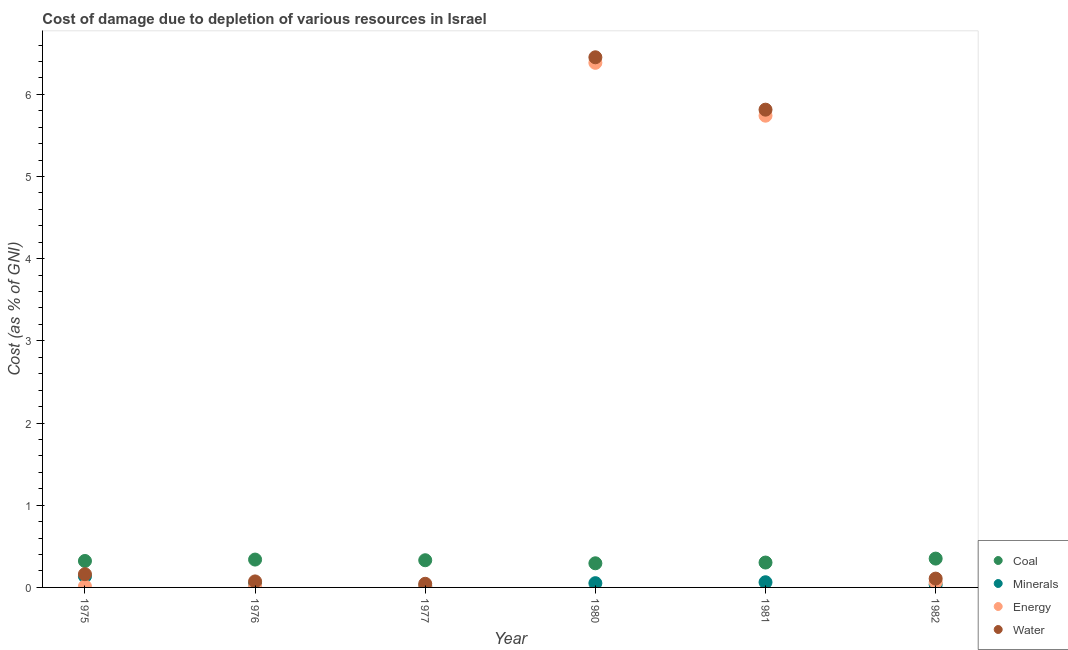How many different coloured dotlines are there?
Ensure brevity in your answer.  4. What is the cost of damage due to depletion of minerals in 1977?
Your response must be concise. 0.02. Across all years, what is the maximum cost of damage due to depletion of coal?
Keep it short and to the point. 0.35. Across all years, what is the minimum cost of damage due to depletion of energy?
Give a very brief answer. 0.01. What is the total cost of damage due to depletion of water in the graph?
Keep it short and to the point. 12.65. What is the difference between the cost of damage due to depletion of coal in 1980 and that in 1981?
Offer a very short reply. -0.01. What is the difference between the cost of damage due to depletion of water in 1980 and the cost of damage due to depletion of coal in 1977?
Give a very brief answer. 6.12. What is the average cost of damage due to depletion of minerals per year?
Ensure brevity in your answer.  0.06. In the year 1976, what is the difference between the cost of damage due to depletion of coal and cost of damage due to depletion of water?
Keep it short and to the point. 0.27. What is the ratio of the cost of damage due to depletion of coal in 1976 to that in 1981?
Your response must be concise. 1.12. Is the cost of damage due to depletion of minerals in 1976 less than that in 1981?
Your answer should be compact. Yes. Is the difference between the cost of damage due to depletion of coal in 1980 and 1982 greater than the difference between the cost of damage due to depletion of energy in 1980 and 1982?
Your answer should be compact. No. What is the difference between the highest and the second highest cost of damage due to depletion of energy?
Give a very brief answer. 0.64. What is the difference between the highest and the lowest cost of damage due to depletion of coal?
Make the answer very short. 0.06. Is the sum of the cost of damage due to depletion of coal in 1975 and 1980 greater than the maximum cost of damage due to depletion of energy across all years?
Keep it short and to the point. No. Is it the case that in every year, the sum of the cost of damage due to depletion of coal and cost of damage due to depletion of energy is greater than the sum of cost of damage due to depletion of minerals and cost of damage due to depletion of water?
Provide a succinct answer. No. Does the cost of damage due to depletion of minerals monotonically increase over the years?
Make the answer very short. No. Does the graph contain any zero values?
Your response must be concise. No. Where does the legend appear in the graph?
Ensure brevity in your answer.  Bottom right. How many legend labels are there?
Offer a terse response. 4. What is the title of the graph?
Provide a short and direct response. Cost of damage due to depletion of various resources in Israel . Does "Primary" appear as one of the legend labels in the graph?
Offer a very short reply. No. What is the label or title of the X-axis?
Offer a terse response. Year. What is the label or title of the Y-axis?
Your answer should be very brief. Cost (as % of GNI). What is the Cost (as % of GNI) of Coal in 1975?
Your answer should be very brief. 0.32. What is the Cost (as % of GNI) in Minerals in 1975?
Offer a very short reply. 0.13. What is the Cost (as % of GNI) in Energy in 1975?
Give a very brief answer. 0.01. What is the Cost (as % of GNI) of Water in 1975?
Make the answer very short. 0.16. What is the Cost (as % of GNI) of Coal in 1976?
Your response must be concise. 0.34. What is the Cost (as % of GNI) of Minerals in 1976?
Give a very brief answer. 0.04. What is the Cost (as % of GNI) in Energy in 1976?
Your answer should be compact. 0.01. What is the Cost (as % of GNI) in Water in 1976?
Your answer should be very brief. 0.07. What is the Cost (as % of GNI) in Coal in 1977?
Ensure brevity in your answer.  0.33. What is the Cost (as % of GNI) in Minerals in 1977?
Your answer should be compact. 0.02. What is the Cost (as % of GNI) of Energy in 1977?
Your answer should be compact. 0.01. What is the Cost (as % of GNI) of Water in 1977?
Offer a terse response. 0.04. What is the Cost (as % of GNI) of Coal in 1980?
Provide a succinct answer. 0.29. What is the Cost (as % of GNI) in Minerals in 1980?
Offer a terse response. 0.05. What is the Cost (as % of GNI) in Energy in 1980?
Give a very brief answer. 6.38. What is the Cost (as % of GNI) in Water in 1980?
Provide a succinct answer. 6.45. What is the Cost (as % of GNI) of Coal in 1981?
Your answer should be very brief. 0.3. What is the Cost (as % of GNI) of Minerals in 1981?
Give a very brief answer. 0.06. What is the Cost (as % of GNI) in Energy in 1981?
Your answer should be very brief. 5.74. What is the Cost (as % of GNI) in Water in 1981?
Your response must be concise. 5.81. What is the Cost (as % of GNI) in Coal in 1982?
Give a very brief answer. 0.35. What is the Cost (as % of GNI) of Minerals in 1982?
Provide a succinct answer. 0.03. What is the Cost (as % of GNI) in Energy in 1982?
Ensure brevity in your answer.  0.06. What is the Cost (as % of GNI) of Water in 1982?
Your answer should be compact. 0.11. Across all years, what is the maximum Cost (as % of GNI) of Coal?
Provide a succinct answer. 0.35. Across all years, what is the maximum Cost (as % of GNI) of Minerals?
Offer a very short reply. 0.13. Across all years, what is the maximum Cost (as % of GNI) in Energy?
Make the answer very short. 6.38. Across all years, what is the maximum Cost (as % of GNI) in Water?
Provide a short and direct response. 6.45. Across all years, what is the minimum Cost (as % of GNI) of Coal?
Offer a terse response. 0.29. Across all years, what is the minimum Cost (as % of GNI) of Minerals?
Provide a short and direct response. 0.02. Across all years, what is the minimum Cost (as % of GNI) in Energy?
Provide a short and direct response. 0.01. Across all years, what is the minimum Cost (as % of GNI) of Water?
Offer a terse response. 0.04. What is the total Cost (as % of GNI) of Coal in the graph?
Offer a very short reply. 1.94. What is the total Cost (as % of GNI) of Minerals in the graph?
Make the answer very short. 0.35. What is the total Cost (as % of GNI) of Energy in the graph?
Keep it short and to the point. 12.22. What is the total Cost (as % of GNI) of Water in the graph?
Provide a succinct answer. 12.65. What is the difference between the Cost (as % of GNI) of Coal in 1975 and that in 1976?
Keep it short and to the point. -0.02. What is the difference between the Cost (as % of GNI) in Minerals in 1975 and that in 1976?
Provide a succinct answer. 0.09. What is the difference between the Cost (as % of GNI) in Energy in 1975 and that in 1976?
Your answer should be very brief. 0. What is the difference between the Cost (as % of GNI) of Water in 1975 and that in 1976?
Your answer should be compact. 0.09. What is the difference between the Cost (as % of GNI) of Coal in 1975 and that in 1977?
Provide a short and direct response. -0.01. What is the difference between the Cost (as % of GNI) in Minerals in 1975 and that in 1977?
Ensure brevity in your answer.  0.12. What is the difference between the Cost (as % of GNI) of Energy in 1975 and that in 1977?
Your response must be concise. 0. What is the difference between the Cost (as % of GNI) in Water in 1975 and that in 1977?
Provide a short and direct response. 0.12. What is the difference between the Cost (as % of GNI) of Coal in 1975 and that in 1980?
Keep it short and to the point. 0.03. What is the difference between the Cost (as % of GNI) of Minerals in 1975 and that in 1980?
Provide a short and direct response. 0.08. What is the difference between the Cost (as % of GNI) of Energy in 1975 and that in 1980?
Your response must be concise. -6.37. What is the difference between the Cost (as % of GNI) in Water in 1975 and that in 1980?
Provide a short and direct response. -6.29. What is the difference between the Cost (as % of GNI) in Coal in 1975 and that in 1981?
Offer a very short reply. 0.02. What is the difference between the Cost (as % of GNI) of Minerals in 1975 and that in 1981?
Your response must be concise. 0.07. What is the difference between the Cost (as % of GNI) of Energy in 1975 and that in 1981?
Make the answer very short. -5.73. What is the difference between the Cost (as % of GNI) in Water in 1975 and that in 1981?
Keep it short and to the point. -5.65. What is the difference between the Cost (as % of GNI) in Coal in 1975 and that in 1982?
Your answer should be very brief. -0.03. What is the difference between the Cost (as % of GNI) in Minerals in 1975 and that in 1982?
Ensure brevity in your answer.  0.1. What is the difference between the Cost (as % of GNI) of Energy in 1975 and that in 1982?
Ensure brevity in your answer.  -0.05. What is the difference between the Cost (as % of GNI) in Water in 1975 and that in 1982?
Give a very brief answer. 0.05. What is the difference between the Cost (as % of GNI) of Coal in 1976 and that in 1977?
Offer a terse response. 0.01. What is the difference between the Cost (as % of GNI) in Minerals in 1976 and that in 1977?
Your answer should be compact. 0.03. What is the difference between the Cost (as % of GNI) in Energy in 1976 and that in 1977?
Ensure brevity in your answer.  0. What is the difference between the Cost (as % of GNI) of Water in 1976 and that in 1977?
Your answer should be very brief. 0.03. What is the difference between the Cost (as % of GNI) of Coal in 1976 and that in 1980?
Ensure brevity in your answer.  0.05. What is the difference between the Cost (as % of GNI) in Minerals in 1976 and that in 1980?
Ensure brevity in your answer.  -0.01. What is the difference between the Cost (as % of GNI) of Energy in 1976 and that in 1980?
Provide a succinct answer. -6.37. What is the difference between the Cost (as % of GNI) of Water in 1976 and that in 1980?
Your answer should be very brief. -6.38. What is the difference between the Cost (as % of GNI) of Coal in 1976 and that in 1981?
Your answer should be compact. 0.04. What is the difference between the Cost (as % of GNI) of Minerals in 1976 and that in 1981?
Your answer should be compact. -0.02. What is the difference between the Cost (as % of GNI) in Energy in 1976 and that in 1981?
Your response must be concise. -5.73. What is the difference between the Cost (as % of GNI) in Water in 1976 and that in 1981?
Provide a succinct answer. -5.74. What is the difference between the Cost (as % of GNI) of Coal in 1976 and that in 1982?
Your answer should be compact. -0.01. What is the difference between the Cost (as % of GNI) in Minerals in 1976 and that in 1982?
Ensure brevity in your answer.  0.01. What is the difference between the Cost (as % of GNI) in Energy in 1976 and that in 1982?
Provide a succinct answer. -0.05. What is the difference between the Cost (as % of GNI) in Water in 1976 and that in 1982?
Provide a succinct answer. -0.03. What is the difference between the Cost (as % of GNI) in Coal in 1977 and that in 1980?
Provide a short and direct response. 0.04. What is the difference between the Cost (as % of GNI) in Minerals in 1977 and that in 1980?
Your answer should be compact. -0.03. What is the difference between the Cost (as % of GNI) of Energy in 1977 and that in 1980?
Provide a succinct answer. -6.37. What is the difference between the Cost (as % of GNI) of Water in 1977 and that in 1980?
Your answer should be compact. -6.41. What is the difference between the Cost (as % of GNI) in Coal in 1977 and that in 1981?
Your answer should be very brief. 0.03. What is the difference between the Cost (as % of GNI) in Minerals in 1977 and that in 1981?
Ensure brevity in your answer.  -0.05. What is the difference between the Cost (as % of GNI) in Energy in 1977 and that in 1981?
Your answer should be very brief. -5.73. What is the difference between the Cost (as % of GNI) of Water in 1977 and that in 1981?
Your answer should be very brief. -5.77. What is the difference between the Cost (as % of GNI) of Coal in 1977 and that in 1982?
Offer a terse response. -0.02. What is the difference between the Cost (as % of GNI) of Minerals in 1977 and that in 1982?
Offer a terse response. -0.02. What is the difference between the Cost (as % of GNI) of Energy in 1977 and that in 1982?
Give a very brief answer. -0.05. What is the difference between the Cost (as % of GNI) in Water in 1977 and that in 1982?
Your answer should be very brief. -0.06. What is the difference between the Cost (as % of GNI) in Coal in 1980 and that in 1981?
Make the answer very short. -0.01. What is the difference between the Cost (as % of GNI) of Minerals in 1980 and that in 1981?
Your response must be concise. -0.01. What is the difference between the Cost (as % of GNI) of Energy in 1980 and that in 1981?
Provide a succinct answer. 0.64. What is the difference between the Cost (as % of GNI) of Water in 1980 and that in 1981?
Provide a succinct answer. 0.64. What is the difference between the Cost (as % of GNI) in Coal in 1980 and that in 1982?
Keep it short and to the point. -0.06. What is the difference between the Cost (as % of GNI) of Minerals in 1980 and that in 1982?
Your response must be concise. 0.02. What is the difference between the Cost (as % of GNI) in Energy in 1980 and that in 1982?
Your answer should be very brief. 6.32. What is the difference between the Cost (as % of GNI) of Water in 1980 and that in 1982?
Provide a short and direct response. 6.34. What is the difference between the Cost (as % of GNI) in Coal in 1981 and that in 1982?
Ensure brevity in your answer.  -0.05. What is the difference between the Cost (as % of GNI) in Minerals in 1981 and that in 1982?
Provide a succinct answer. 0.03. What is the difference between the Cost (as % of GNI) in Energy in 1981 and that in 1982?
Your response must be concise. 5.68. What is the difference between the Cost (as % of GNI) in Water in 1981 and that in 1982?
Offer a very short reply. 5.71. What is the difference between the Cost (as % of GNI) of Coal in 1975 and the Cost (as % of GNI) of Minerals in 1976?
Your response must be concise. 0.28. What is the difference between the Cost (as % of GNI) in Coal in 1975 and the Cost (as % of GNI) in Energy in 1976?
Your answer should be compact. 0.31. What is the difference between the Cost (as % of GNI) of Coal in 1975 and the Cost (as % of GNI) of Water in 1976?
Keep it short and to the point. 0.25. What is the difference between the Cost (as % of GNI) of Minerals in 1975 and the Cost (as % of GNI) of Energy in 1976?
Ensure brevity in your answer.  0.12. What is the difference between the Cost (as % of GNI) in Minerals in 1975 and the Cost (as % of GNI) in Water in 1976?
Ensure brevity in your answer.  0.06. What is the difference between the Cost (as % of GNI) of Energy in 1975 and the Cost (as % of GNI) of Water in 1976?
Provide a succinct answer. -0.06. What is the difference between the Cost (as % of GNI) in Coal in 1975 and the Cost (as % of GNI) in Minerals in 1977?
Provide a short and direct response. 0.3. What is the difference between the Cost (as % of GNI) of Coal in 1975 and the Cost (as % of GNI) of Energy in 1977?
Your answer should be very brief. 0.31. What is the difference between the Cost (as % of GNI) in Coal in 1975 and the Cost (as % of GNI) in Water in 1977?
Your response must be concise. 0.28. What is the difference between the Cost (as % of GNI) of Minerals in 1975 and the Cost (as % of GNI) of Energy in 1977?
Your answer should be very brief. 0.12. What is the difference between the Cost (as % of GNI) of Minerals in 1975 and the Cost (as % of GNI) of Water in 1977?
Offer a terse response. 0.09. What is the difference between the Cost (as % of GNI) of Energy in 1975 and the Cost (as % of GNI) of Water in 1977?
Your answer should be very brief. -0.03. What is the difference between the Cost (as % of GNI) in Coal in 1975 and the Cost (as % of GNI) in Minerals in 1980?
Keep it short and to the point. 0.27. What is the difference between the Cost (as % of GNI) in Coal in 1975 and the Cost (as % of GNI) in Energy in 1980?
Make the answer very short. -6.06. What is the difference between the Cost (as % of GNI) in Coal in 1975 and the Cost (as % of GNI) in Water in 1980?
Provide a succinct answer. -6.13. What is the difference between the Cost (as % of GNI) of Minerals in 1975 and the Cost (as % of GNI) of Energy in 1980?
Your answer should be very brief. -6.25. What is the difference between the Cost (as % of GNI) in Minerals in 1975 and the Cost (as % of GNI) in Water in 1980?
Make the answer very short. -6.32. What is the difference between the Cost (as % of GNI) in Energy in 1975 and the Cost (as % of GNI) in Water in 1980?
Your response must be concise. -6.44. What is the difference between the Cost (as % of GNI) of Coal in 1975 and the Cost (as % of GNI) of Minerals in 1981?
Make the answer very short. 0.26. What is the difference between the Cost (as % of GNI) of Coal in 1975 and the Cost (as % of GNI) of Energy in 1981?
Give a very brief answer. -5.42. What is the difference between the Cost (as % of GNI) of Coal in 1975 and the Cost (as % of GNI) of Water in 1981?
Make the answer very short. -5.49. What is the difference between the Cost (as % of GNI) of Minerals in 1975 and the Cost (as % of GNI) of Energy in 1981?
Ensure brevity in your answer.  -5.61. What is the difference between the Cost (as % of GNI) in Minerals in 1975 and the Cost (as % of GNI) in Water in 1981?
Your answer should be very brief. -5.68. What is the difference between the Cost (as % of GNI) in Energy in 1975 and the Cost (as % of GNI) in Water in 1981?
Your answer should be compact. -5.8. What is the difference between the Cost (as % of GNI) of Coal in 1975 and the Cost (as % of GNI) of Minerals in 1982?
Offer a terse response. 0.29. What is the difference between the Cost (as % of GNI) in Coal in 1975 and the Cost (as % of GNI) in Energy in 1982?
Provide a succinct answer. 0.26. What is the difference between the Cost (as % of GNI) of Coal in 1975 and the Cost (as % of GNI) of Water in 1982?
Keep it short and to the point. 0.21. What is the difference between the Cost (as % of GNI) of Minerals in 1975 and the Cost (as % of GNI) of Energy in 1982?
Provide a short and direct response. 0.07. What is the difference between the Cost (as % of GNI) in Minerals in 1975 and the Cost (as % of GNI) in Water in 1982?
Your answer should be very brief. 0.03. What is the difference between the Cost (as % of GNI) in Energy in 1975 and the Cost (as % of GNI) in Water in 1982?
Your answer should be compact. -0.09. What is the difference between the Cost (as % of GNI) in Coal in 1976 and the Cost (as % of GNI) in Minerals in 1977?
Ensure brevity in your answer.  0.32. What is the difference between the Cost (as % of GNI) in Coal in 1976 and the Cost (as % of GNI) in Energy in 1977?
Make the answer very short. 0.33. What is the difference between the Cost (as % of GNI) of Coal in 1976 and the Cost (as % of GNI) of Water in 1977?
Your answer should be very brief. 0.29. What is the difference between the Cost (as % of GNI) in Minerals in 1976 and the Cost (as % of GNI) in Energy in 1977?
Your answer should be compact. 0.03. What is the difference between the Cost (as % of GNI) in Minerals in 1976 and the Cost (as % of GNI) in Water in 1977?
Your response must be concise. -0. What is the difference between the Cost (as % of GNI) of Energy in 1976 and the Cost (as % of GNI) of Water in 1977?
Your answer should be compact. -0.03. What is the difference between the Cost (as % of GNI) in Coal in 1976 and the Cost (as % of GNI) in Minerals in 1980?
Your answer should be very brief. 0.29. What is the difference between the Cost (as % of GNI) in Coal in 1976 and the Cost (as % of GNI) in Energy in 1980?
Your response must be concise. -6.04. What is the difference between the Cost (as % of GNI) of Coal in 1976 and the Cost (as % of GNI) of Water in 1980?
Keep it short and to the point. -6.11. What is the difference between the Cost (as % of GNI) of Minerals in 1976 and the Cost (as % of GNI) of Energy in 1980?
Your answer should be very brief. -6.34. What is the difference between the Cost (as % of GNI) of Minerals in 1976 and the Cost (as % of GNI) of Water in 1980?
Make the answer very short. -6.41. What is the difference between the Cost (as % of GNI) in Energy in 1976 and the Cost (as % of GNI) in Water in 1980?
Give a very brief answer. -6.44. What is the difference between the Cost (as % of GNI) of Coal in 1976 and the Cost (as % of GNI) of Minerals in 1981?
Your answer should be compact. 0.28. What is the difference between the Cost (as % of GNI) in Coal in 1976 and the Cost (as % of GNI) in Energy in 1981?
Ensure brevity in your answer.  -5.4. What is the difference between the Cost (as % of GNI) of Coal in 1976 and the Cost (as % of GNI) of Water in 1981?
Provide a succinct answer. -5.47. What is the difference between the Cost (as % of GNI) of Minerals in 1976 and the Cost (as % of GNI) of Energy in 1981?
Your response must be concise. -5.7. What is the difference between the Cost (as % of GNI) in Minerals in 1976 and the Cost (as % of GNI) in Water in 1981?
Provide a short and direct response. -5.77. What is the difference between the Cost (as % of GNI) in Energy in 1976 and the Cost (as % of GNI) in Water in 1981?
Your answer should be compact. -5.8. What is the difference between the Cost (as % of GNI) of Coal in 1976 and the Cost (as % of GNI) of Minerals in 1982?
Keep it short and to the point. 0.3. What is the difference between the Cost (as % of GNI) in Coal in 1976 and the Cost (as % of GNI) in Energy in 1982?
Provide a succinct answer. 0.28. What is the difference between the Cost (as % of GNI) of Coal in 1976 and the Cost (as % of GNI) of Water in 1982?
Offer a very short reply. 0.23. What is the difference between the Cost (as % of GNI) of Minerals in 1976 and the Cost (as % of GNI) of Energy in 1982?
Your answer should be very brief. -0.02. What is the difference between the Cost (as % of GNI) of Minerals in 1976 and the Cost (as % of GNI) of Water in 1982?
Your answer should be compact. -0.06. What is the difference between the Cost (as % of GNI) in Energy in 1976 and the Cost (as % of GNI) in Water in 1982?
Your response must be concise. -0.09. What is the difference between the Cost (as % of GNI) in Coal in 1977 and the Cost (as % of GNI) in Minerals in 1980?
Your answer should be compact. 0.28. What is the difference between the Cost (as % of GNI) of Coal in 1977 and the Cost (as % of GNI) of Energy in 1980?
Your response must be concise. -6.05. What is the difference between the Cost (as % of GNI) of Coal in 1977 and the Cost (as % of GNI) of Water in 1980?
Provide a succinct answer. -6.12. What is the difference between the Cost (as % of GNI) of Minerals in 1977 and the Cost (as % of GNI) of Energy in 1980?
Offer a terse response. -6.37. What is the difference between the Cost (as % of GNI) in Minerals in 1977 and the Cost (as % of GNI) in Water in 1980?
Your answer should be very brief. -6.43. What is the difference between the Cost (as % of GNI) in Energy in 1977 and the Cost (as % of GNI) in Water in 1980?
Ensure brevity in your answer.  -6.44. What is the difference between the Cost (as % of GNI) in Coal in 1977 and the Cost (as % of GNI) in Minerals in 1981?
Provide a short and direct response. 0.27. What is the difference between the Cost (as % of GNI) in Coal in 1977 and the Cost (as % of GNI) in Energy in 1981?
Your answer should be compact. -5.41. What is the difference between the Cost (as % of GNI) of Coal in 1977 and the Cost (as % of GNI) of Water in 1981?
Provide a succinct answer. -5.48. What is the difference between the Cost (as % of GNI) in Minerals in 1977 and the Cost (as % of GNI) in Energy in 1981?
Offer a terse response. -5.72. What is the difference between the Cost (as % of GNI) of Minerals in 1977 and the Cost (as % of GNI) of Water in 1981?
Offer a terse response. -5.8. What is the difference between the Cost (as % of GNI) of Energy in 1977 and the Cost (as % of GNI) of Water in 1981?
Ensure brevity in your answer.  -5.8. What is the difference between the Cost (as % of GNI) of Coal in 1977 and the Cost (as % of GNI) of Minerals in 1982?
Offer a very short reply. 0.3. What is the difference between the Cost (as % of GNI) of Coal in 1977 and the Cost (as % of GNI) of Energy in 1982?
Your answer should be compact. 0.27. What is the difference between the Cost (as % of GNI) in Coal in 1977 and the Cost (as % of GNI) in Water in 1982?
Your answer should be very brief. 0.22. What is the difference between the Cost (as % of GNI) in Minerals in 1977 and the Cost (as % of GNI) in Energy in 1982?
Your answer should be very brief. -0.05. What is the difference between the Cost (as % of GNI) in Minerals in 1977 and the Cost (as % of GNI) in Water in 1982?
Make the answer very short. -0.09. What is the difference between the Cost (as % of GNI) of Energy in 1977 and the Cost (as % of GNI) of Water in 1982?
Your answer should be compact. -0.1. What is the difference between the Cost (as % of GNI) in Coal in 1980 and the Cost (as % of GNI) in Minerals in 1981?
Provide a short and direct response. 0.23. What is the difference between the Cost (as % of GNI) in Coal in 1980 and the Cost (as % of GNI) in Energy in 1981?
Your answer should be compact. -5.45. What is the difference between the Cost (as % of GNI) of Coal in 1980 and the Cost (as % of GNI) of Water in 1981?
Offer a very short reply. -5.52. What is the difference between the Cost (as % of GNI) of Minerals in 1980 and the Cost (as % of GNI) of Energy in 1981?
Your answer should be compact. -5.69. What is the difference between the Cost (as % of GNI) of Minerals in 1980 and the Cost (as % of GNI) of Water in 1981?
Give a very brief answer. -5.76. What is the difference between the Cost (as % of GNI) of Energy in 1980 and the Cost (as % of GNI) of Water in 1981?
Ensure brevity in your answer.  0.57. What is the difference between the Cost (as % of GNI) of Coal in 1980 and the Cost (as % of GNI) of Minerals in 1982?
Make the answer very short. 0.26. What is the difference between the Cost (as % of GNI) of Coal in 1980 and the Cost (as % of GNI) of Energy in 1982?
Your response must be concise. 0.23. What is the difference between the Cost (as % of GNI) in Coal in 1980 and the Cost (as % of GNI) in Water in 1982?
Your answer should be compact. 0.19. What is the difference between the Cost (as % of GNI) of Minerals in 1980 and the Cost (as % of GNI) of Energy in 1982?
Your response must be concise. -0.01. What is the difference between the Cost (as % of GNI) in Minerals in 1980 and the Cost (as % of GNI) in Water in 1982?
Offer a terse response. -0.06. What is the difference between the Cost (as % of GNI) of Energy in 1980 and the Cost (as % of GNI) of Water in 1982?
Provide a short and direct response. 6.28. What is the difference between the Cost (as % of GNI) in Coal in 1981 and the Cost (as % of GNI) in Minerals in 1982?
Ensure brevity in your answer.  0.27. What is the difference between the Cost (as % of GNI) in Coal in 1981 and the Cost (as % of GNI) in Energy in 1982?
Offer a very short reply. 0.24. What is the difference between the Cost (as % of GNI) in Coal in 1981 and the Cost (as % of GNI) in Water in 1982?
Provide a succinct answer. 0.2. What is the difference between the Cost (as % of GNI) in Minerals in 1981 and the Cost (as % of GNI) in Water in 1982?
Make the answer very short. -0.04. What is the difference between the Cost (as % of GNI) of Energy in 1981 and the Cost (as % of GNI) of Water in 1982?
Your response must be concise. 5.63. What is the average Cost (as % of GNI) in Coal per year?
Provide a succinct answer. 0.32. What is the average Cost (as % of GNI) of Minerals per year?
Offer a very short reply. 0.06. What is the average Cost (as % of GNI) of Energy per year?
Ensure brevity in your answer.  2.04. What is the average Cost (as % of GNI) in Water per year?
Your response must be concise. 2.11. In the year 1975, what is the difference between the Cost (as % of GNI) in Coal and Cost (as % of GNI) in Minerals?
Your answer should be compact. 0.19. In the year 1975, what is the difference between the Cost (as % of GNI) of Coal and Cost (as % of GNI) of Energy?
Your answer should be very brief. 0.31. In the year 1975, what is the difference between the Cost (as % of GNI) in Coal and Cost (as % of GNI) in Water?
Keep it short and to the point. 0.16. In the year 1975, what is the difference between the Cost (as % of GNI) in Minerals and Cost (as % of GNI) in Energy?
Your answer should be compact. 0.12. In the year 1975, what is the difference between the Cost (as % of GNI) in Minerals and Cost (as % of GNI) in Water?
Your answer should be compact. -0.03. In the year 1975, what is the difference between the Cost (as % of GNI) of Energy and Cost (as % of GNI) of Water?
Your answer should be compact. -0.15. In the year 1976, what is the difference between the Cost (as % of GNI) in Coal and Cost (as % of GNI) in Minerals?
Ensure brevity in your answer.  0.3. In the year 1976, what is the difference between the Cost (as % of GNI) in Coal and Cost (as % of GNI) in Energy?
Ensure brevity in your answer.  0.33. In the year 1976, what is the difference between the Cost (as % of GNI) in Coal and Cost (as % of GNI) in Water?
Make the answer very short. 0.27. In the year 1976, what is the difference between the Cost (as % of GNI) in Minerals and Cost (as % of GNI) in Energy?
Give a very brief answer. 0.03. In the year 1976, what is the difference between the Cost (as % of GNI) of Minerals and Cost (as % of GNI) of Water?
Make the answer very short. -0.03. In the year 1976, what is the difference between the Cost (as % of GNI) in Energy and Cost (as % of GNI) in Water?
Your answer should be very brief. -0.06. In the year 1977, what is the difference between the Cost (as % of GNI) in Coal and Cost (as % of GNI) in Minerals?
Provide a succinct answer. 0.31. In the year 1977, what is the difference between the Cost (as % of GNI) in Coal and Cost (as % of GNI) in Energy?
Give a very brief answer. 0.32. In the year 1977, what is the difference between the Cost (as % of GNI) in Coal and Cost (as % of GNI) in Water?
Your answer should be compact. 0.29. In the year 1977, what is the difference between the Cost (as % of GNI) of Minerals and Cost (as % of GNI) of Energy?
Keep it short and to the point. 0.01. In the year 1977, what is the difference between the Cost (as % of GNI) in Minerals and Cost (as % of GNI) in Water?
Provide a short and direct response. -0.03. In the year 1977, what is the difference between the Cost (as % of GNI) of Energy and Cost (as % of GNI) of Water?
Offer a very short reply. -0.03. In the year 1980, what is the difference between the Cost (as % of GNI) in Coal and Cost (as % of GNI) in Minerals?
Provide a short and direct response. 0.24. In the year 1980, what is the difference between the Cost (as % of GNI) of Coal and Cost (as % of GNI) of Energy?
Keep it short and to the point. -6.09. In the year 1980, what is the difference between the Cost (as % of GNI) in Coal and Cost (as % of GNI) in Water?
Your answer should be compact. -6.16. In the year 1980, what is the difference between the Cost (as % of GNI) of Minerals and Cost (as % of GNI) of Energy?
Your answer should be very brief. -6.33. In the year 1980, what is the difference between the Cost (as % of GNI) of Minerals and Cost (as % of GNI) of Water?
Provide a succinct answer. -6.4. In the year 1980, what is the difference between the Cost (as % of GNI) in Energy and Cost (as % of GNI) in Water?
Provide a short and direct response. -0.07. In the year 1981, what is the difference between the Cost (as % of GNI) in Coal and Cost (as % of GNI) in Minerals?
Keep it short and to the point. 0.24. In the year 1981, what is the difference between the Cost (as % of GNI) of Coal and Cost (as % of GNI) of Energy?
Your answer should be very brief. -5.44. In the year 1981, what is the difference between the Cost (as % of GNI) in Coal and Cost (as % of GNI) in Water?
Ensure brevity in your answer.  -5.51. In the year 1981, what is the difference between the Cost (as % of GNI) of Minerals and Cost (as % of GNI) of Energy?
Your answer should be compact. -5.68. In the year 1981, what is the difference between the Cost (as % of GNI) in Minerals and Cost (as % of GNI) in Water?
Provide a succinct answer. -5.75. In the year 1981, what is the difference between the Cost (as % of GNI) in Energy and Cost (as % of GNI) in Water?
Give a very brief answer. -0.07. In the year 1982, what is the difference between the Cost (as % of GNI) in Coal and Cost (as % of GNI) in Minerals?
Offer a very short reply. 0.32. In the year 1982, what is the difference between the Cost (as % of GNI) of Coal and Cost (as % of GNI) of Energy?
Provide a succinct answer. 0.29. In the year 1982, what is the difference between the Cost (as % of GNI) of Coal and Cost (as % of GNI) of Water?
Make the answer very short. 0.24. In the year 1982, what is the difference between the Cost (as % of GNI) of Minerals and Cost (as % of GNI) of Energy?
Offer a very short reply. -0.03. In the year 1982, what is the difference between the Cost (as % of GNI) of Minerals and Cost (as % of GNI) of Water?
Offer a very short reply. -0.07. In the year 1982, what is the difference between the Cost (as % of GNI) in Energy and Cost (as % of GNI) in Water?
Your response must be concise. -0.04. What is the ratio of the Cost (as % of GNI) in Coal in 1975 to that in 1976?
Your answer should be compact. 0.95. What is the ratio of the Cost (as % of GNI) of Minerals in 1975 to that in 1976?
Your answer should be very brief. 3.09. What is the ratio of the Cost (as % of GNI) of Energy in 1975 to that in 1976?
Your answer should be compact. 1.05. What is the ratio of the Cost (as % of GNI) of Water in 1975 to that in 1976?
Offer a very short reply. 2.2. What is the ratio of the Cost (as % of GNI) in Coal in 1975 to that in 1977?
Keep it short and to the point. 0.97. What is the ratio of the Cost (as % of GNI) in Minerals in 1975 to that in 1977?
Give a very brief answer. 7.65. What is the ratio of the Cost (as % of GNI) in Energy in 1975 to that in 1977?
Your answer should be compact. 1.12. What is the ratio of the Cost (as % of GNI) of Water in 1975 to that in 1977?
Offer a very short reply. 3.64. What is the ratio of the Cost (as % of GNI) in Coal in 1975 to that in 1980?
Your answer should be very brief. 1.1. What is the ratio of the Cost (as % of GNI) of Minerals in 1975 to that in 1980?
Offer a terse response. 2.61. What is the ratio of the Cost (as % of GNI) of Energy in 1975 to that in 1980?
Your answer should be very brief. 0. What is the ratio of the Cost (as % of GNI) of Water in 1975 to that in 1980?
Provide a short and direct response. 0.03. What is the ratio of the Cost (as % of GNI) in Coal in 1975 to that in 1981?
Keep it short and to the point. 1.06. What is the ratio of the Cost (as % of GNI) of Minerals in 1975 to that in 1981?
Offer a terse response. 2.14. What is the ratio of the Cost (as % of GNI) in Energy in 1975 to that in 1981?
Provide a short and direct response. 0. What is the ratio of the Cost (as % of GNI) of Water in 1975 to that in 1981?
Your response must be concise. 0.03. What is the ratio of the Cost (as % of GNI) in Coal in 1975 to that in 1982?
Offer a very short reply. 0.92. What is the ratio of the Cost (as % of GNI) in Minerals in 1975 to that in 1982?
Provide a short and direct response. 3.95. What is the ratio of the Cost (as % of GNI) in Energy in 1975 to that in 1982?
Provide a succinct answer. 0.21. What is the ratio of the Cost (as % of GNI) in Water in 1975 to that in 1982?
Your answer should be compact. 1.5. What is the ratio of the Cost (as % of GNI) in Coal in 1976 to that in 1977?
Your response must be concise. 1.02. What is the ratio of the Cost (as % of GNI) in Minerals in 1976 to that in 1977?
Ensure brevity in your answer.  2.48. What is the ratio of the Cost (as % of GNI) of Energy in 1976 to that in 1977?
Offer a very short reply. 1.07. What is the ratio of the Cost (as % of GNI) in Water in 1976 to that in 1977?
Ensure brevity in your answer.  1.65. What is the ratio of the Cost (as % of GNI) of Coal in 1976 to that in 1980?
Keep it short and to the point. 1.15. What is the ratio of the Cost (as % of GNI) in Minerals in 1976 to that in 1980?
Your answer should be very brief. 0.84. What is the ratio of the Cost (as % of GNI) of Energy in 1976 to that in 1980?
Make the answer very short. 0. What is the ratio of the Cost (as % of GNI) of Water in 1976 to that in 1980?
Your answer should be compact. 0.01. What is the ratio of the Cost (as % of GNI) of Coal in 1976 to that in 1981?
Provide a succinct answer. 1.12. What is the ratio of the Cost (as % of GNI) of Minerals in 1976 to that in 1981?
Give a very brief answer. 0.69. What is the ratio of the Cost (as % of GNI) of Energy in 1976 to that in 1981?
Provide a short and direct response. 0. What is the ratio of the Cost (as % of GNI) of Water in 1976 to that in 1981?
Make the answer very short. 0.01. What is the ratio of the Cost (as % of GNI) in Coal in 1976 to that in 1982?
Offer a very short reply. 0.97. What is the ratio of the Cost (as % of GNI) in Minerals in 1976 to that in 1982?
Provide a short and direct response. 1.28. What is the ratio of the Cost (as % of GNI) in Energy in 1976 to that in 1982?
Your answer should be very brief. 0.2. What is the ratio of the Cost (as % of GNI) of Water in 1976 to that in 1982?
Make the answer very short. 0.68. What is the ratio of the Cost (as % of GNI) of Coal in 1977 to that in 1980?
Provide a short and direct response. 1.13. What is the ratio of the Cost (as % of GNI) of Minerals in 1977 to that in 1980?
Your answer should be very brief. 0.34. What is the ratio of the Cost (as % of GNI) in Energy in 1977 to that in 1980?
Provide a succinct answer. 0. What is the ratio of the Cost (as % of GNI) in Water in 1977 to that in 1980?
Your answer should be very brief. 0.01. What is the ratio of the Cost (as % of GNI) of Coal in 1977 to that in 1981?
Keep it short and to the point. 1.09. What is the ratio of the Cost (as % of GNI) in Minerals in 1977 to that in 1981?
Give a very brief answer. 0.28. What is the ratio of the Cost (as % of GNI) of Energy in 1977 to that in 1981?
Provide a short and direct response. 0. What is the ratio of the Cost (as % of GNI) in Water in 1977 to that in 1981?
Offer a terse response. 0.01. What is the ratio of the Cost (as % of GNI) of Coal in 1977 to that in 1982?
Ensure brevity in your answer.  0.94. What is the ratio of the Cost (as % of GNI) in Minerals in 1977 to that in 1982?
Your answer should be compact. 0.52. What is the ratio of the Cost (as % of GNI) of Energy in 1977 to that in 1982?
Give a very brief answer. 0.19. What is the ratio of the Cost (as % of GNI) in Water in 1977 to that in 1982?
Your answer should be very brief. 0.41. What is the ratio of the Cost (as % of GNI) of Coal in 1980 to that in 1981?
Your answer should be compact. 0.97. What is the ratio of the Cost (as % of GNI) in Minerals in 1980 to that in 1981?
Your response must be concise. 0.82. What is the ratio of the Cost (as % of GNI) of Energy in 1980 to that in 1981?
Ensure brevity in your answer.  1.11. What is the ratio of the Cost (as % of GNI) in Water in 1980 to that in 1981?
Provide a short and direct response. 1.11. What is the ratio of the Cost (as % of GNI) of Coal in 1980 to that in 1982?
Make the answer very short. 0.84. What is the ratio of the Cost (as % of GNI) of Minerals in 1980 to that in 1982?
Offer a terse response. 1.51. What is the ratio of the Cost (as % of GNI) in Energy in 1980 to that in 1982?
Your answer should be very brief. 101.36. What is the ratio of the Cost (as % of GNI) in Water in 1980 to that in 1982?
Your response must be concise. 60.09. What is the ratio of the Cost (as % of GNI) in Coal in 1981 to that in 1982?
Ensure brevity in your answer.  0.86. What is the ratio of the Cost (as % of GNI) in Minerals in 1981 to that in 1982?
Your answer should be compact. 1.84. What is the ratio of the Cost (as % of GNI) in Energy in 1981 to that in 1982?
Your answer should be very brief. 91.15. What is the ratio of the Cost (as % of GNI) in Water in 1981 to that in 1982?
Offer a terse response. 54.15. What is the difference between the highest and the second highest Cost (as % of GNI) in Coal?
Make the answer very short. 0.01. What is the difference between the highest and the second highest Cost (as % of GNI) of Minerals?
Make the answer very short. 0.07. What is the difference between the highest and the second highest Cost (as % of GNI) in Energy?
Provide a short and direct response. 0.64. What is the difference between the highest and the second highest Cost (as % of GNI) of Water?
Ensure brevity in your answer.  0.64. What is the difference between the highest and the lowest Cost (as % of GNI) in Coal?
Your answer should be very brief. 0.06. What is the difference between the highest and the lowest Cost (as % of GNI) of Minerals?
Ensure brevity in your answer.  0.12. What is the difference between the highest and the lowest Cost (as % of GNI) in Energy?
Make the answer very short. 6.37. What is the difference between the highest and the lowest Cost (as % of GNI) in Water?
Provide a short and direct response. 6.41. 